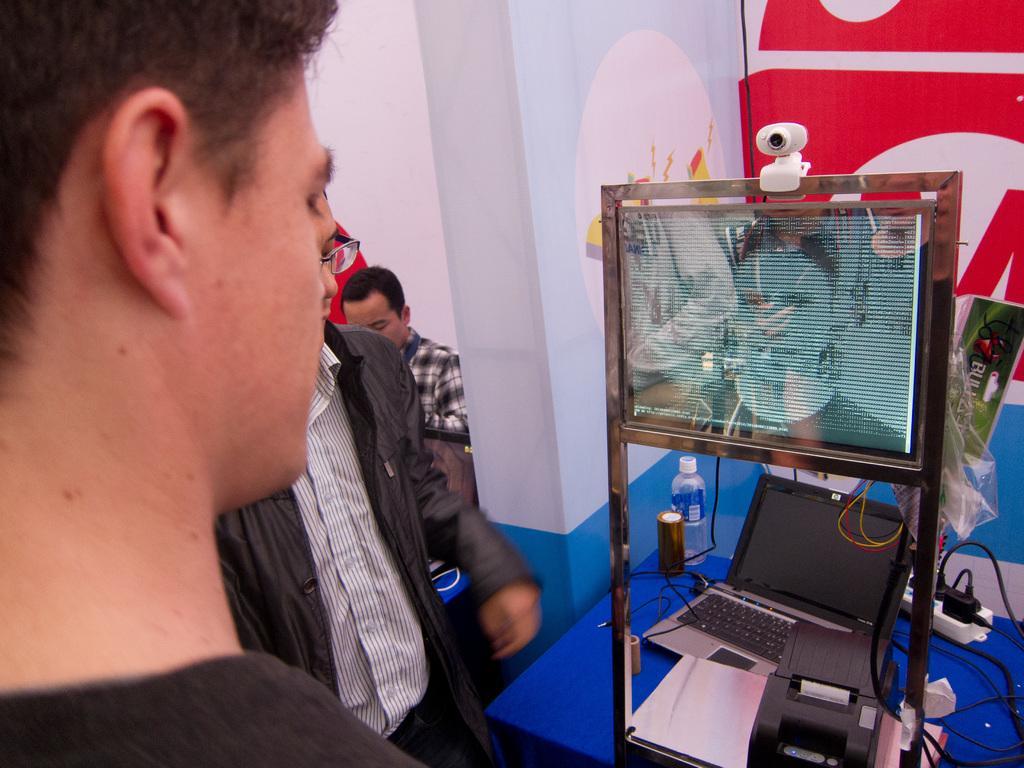How would you summarize this image in a sentence or two? In this image in the front there is a person standing and in the center there is a laptop, there are wires, there is a bottle, there is a screen, there is a camera, there are persons, there is a board with some text written on it. 